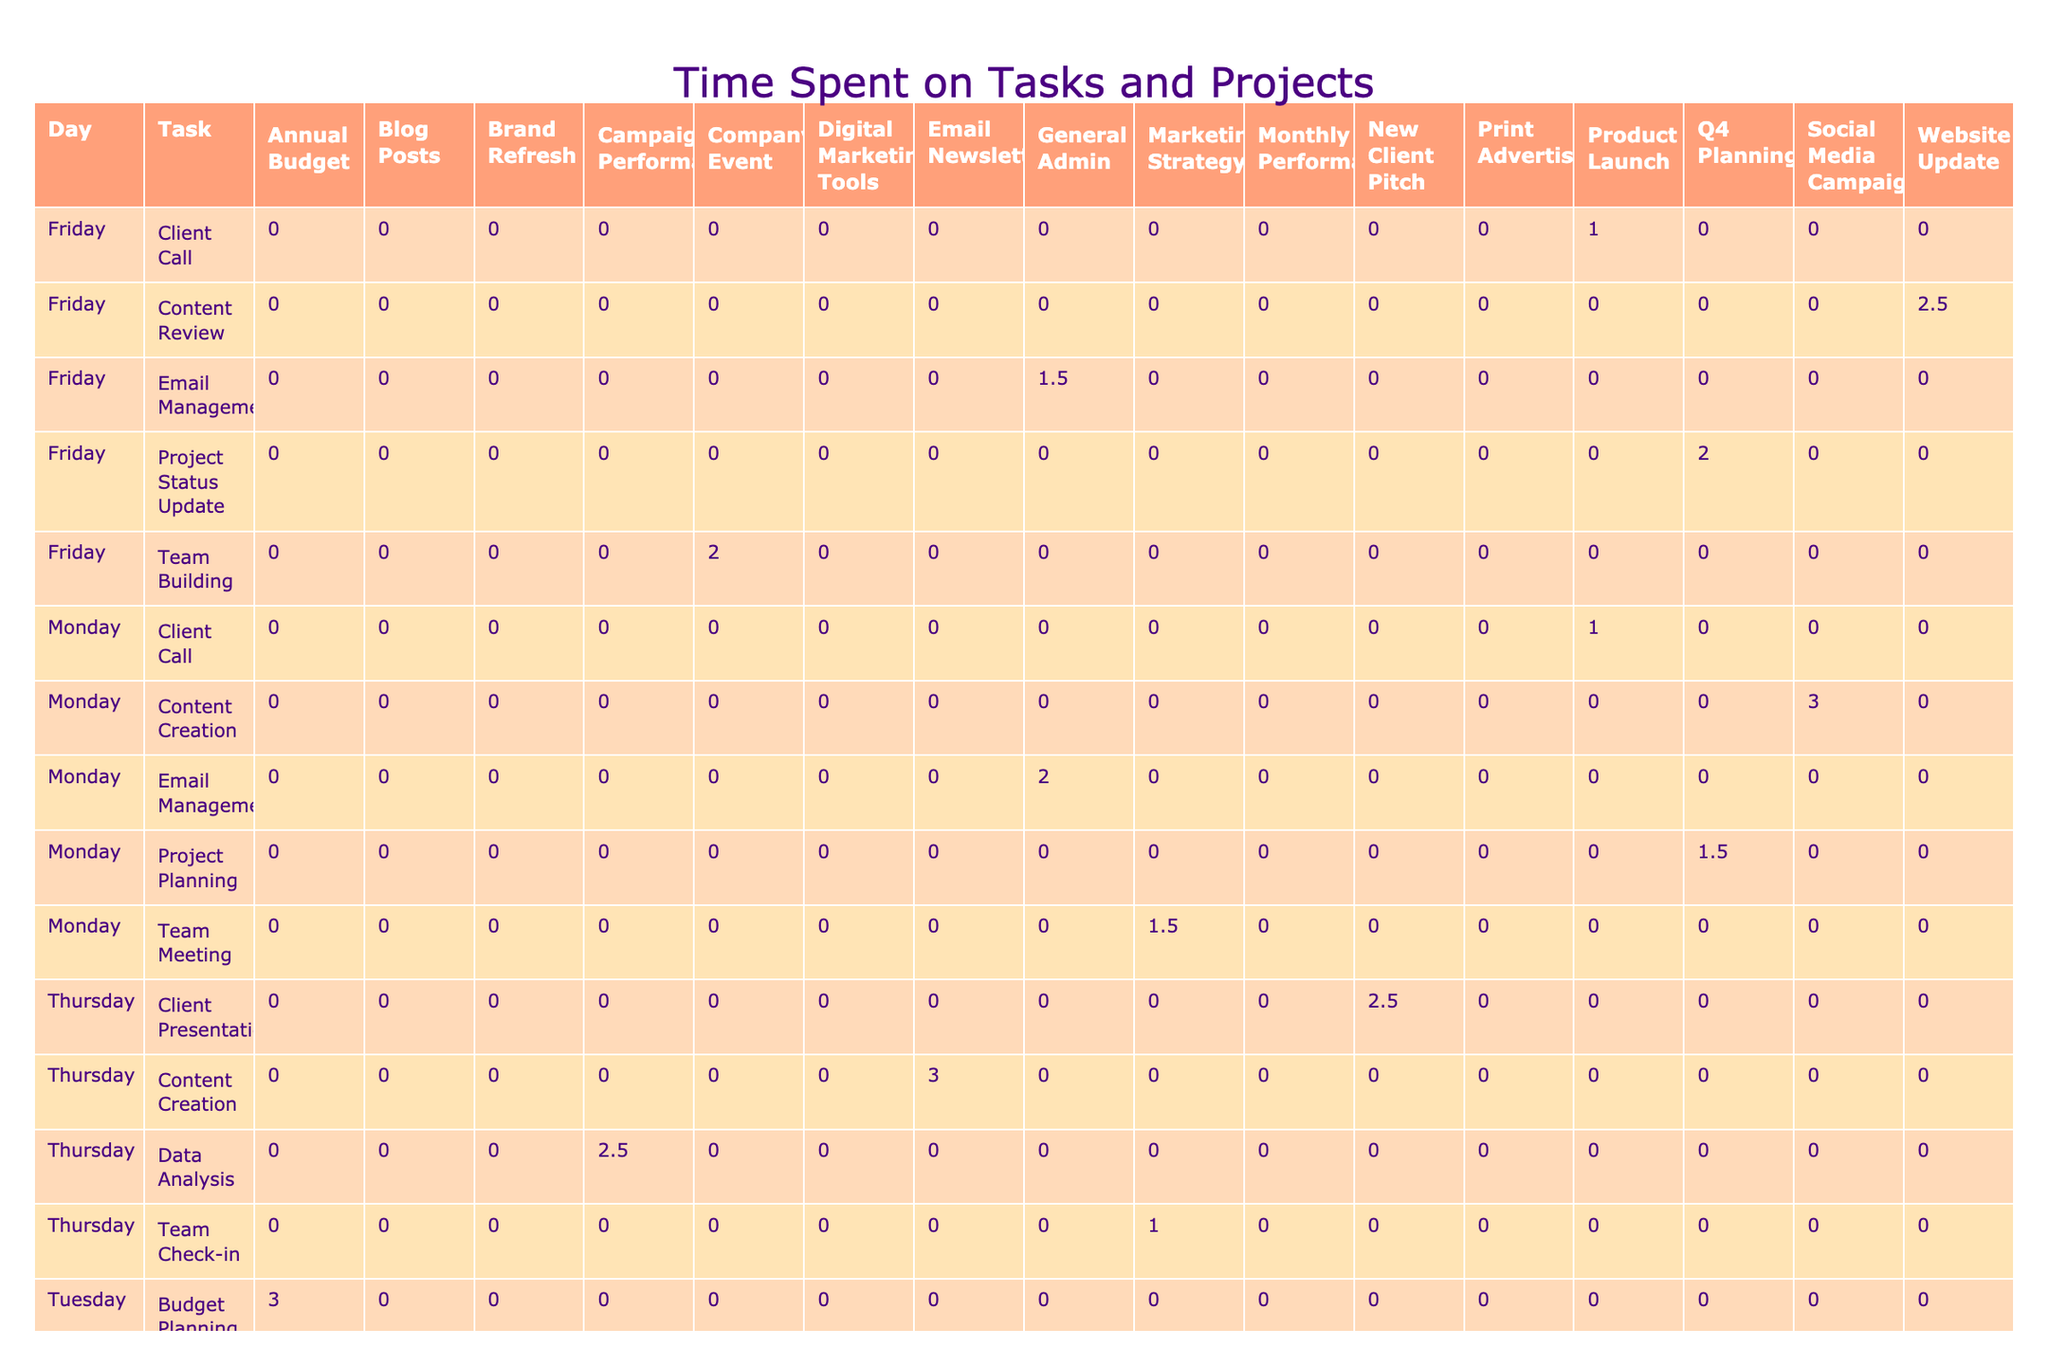What day has the highest total time spent on tasks? By summing the total time spent for each day: Monday (10 hours), Tuesday (9 hours), Wednesday (9 hours), Thursday (9 hours), Friday (9 hours). The highest total is on Monday.
Answer: Monday How much time is spent on "Content Creation" tasks? Adding the time for "Content Creation" under different projects: 3 hours (Social Media Campaign, Monday) + 3 hours (Email Newsletter, Thursday) = 6 hours.
Answer: 6 hours Is the "Team Meeting" task performed more than once during the week? The table lists "Team Meeting" only once, on Monday, so it is not performed more than once.
Answer: No Which task has the highest individual time spent? Analyzing the tasks: "Training Session" has 3 hours, while others are less (2.5 hours for Client Presentation, etc.). Thus, "Training Session" has the highest individual time.
Answer: Training Session What is the total time spent on "Email Management"? Summing the hours across entries for "Email Management": 2 hours (Monday) + 1.5 hours (Wednesday) + 1.5 hours (Friday) = 5 hours total.
Answer: 5 hours Are there any tasks that require less than 1 hour of time? Reviewing the table shows all tasks have at least 1 hour or more recorded, so there are no tasks under this category.
Answer: No What is the average time spent on tasks during Thursday? Calculating the total time for Thursday: 2.5 hours + 1 hour + 3 hours + 2.5 hours = 9 hours. There are 4 tasks, so the average is 9 hours / 4 = 2.25 hours.
Answer: 2.25 hours How many hours were spent on "Client Calls" during the week? Summing the time for "Client Call" entries: 1 hour (Monday) + 1 hour (Friday) = 2 hours total for "Client Calls".
Answer: 2 hours What two projects took the most time combined on Wednesday? Analyzing wait times: "Creative Brainstorming" (2 hours) and "Social Media Scheduling" (2.5 hours) together total 4.5 hours.
Answer: 4.5 hours 